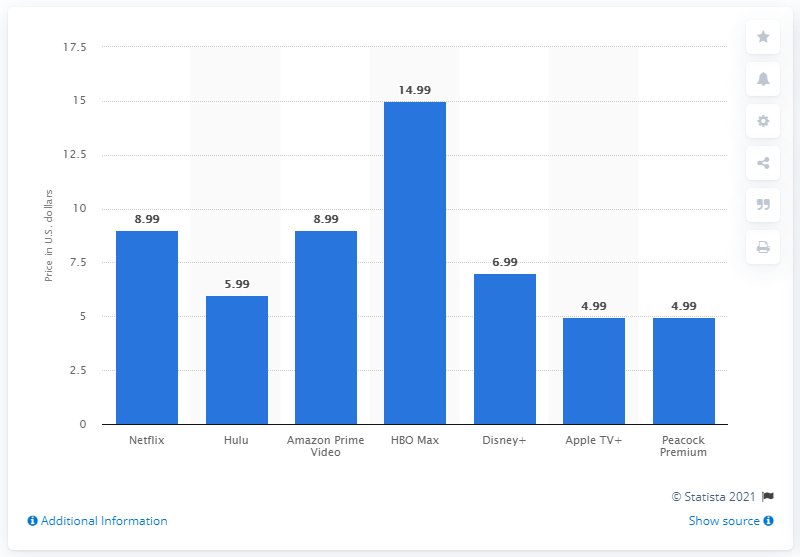Indicate a few pertinent items in this graphic. Amazon Prime Video cost $8.99 per month. 